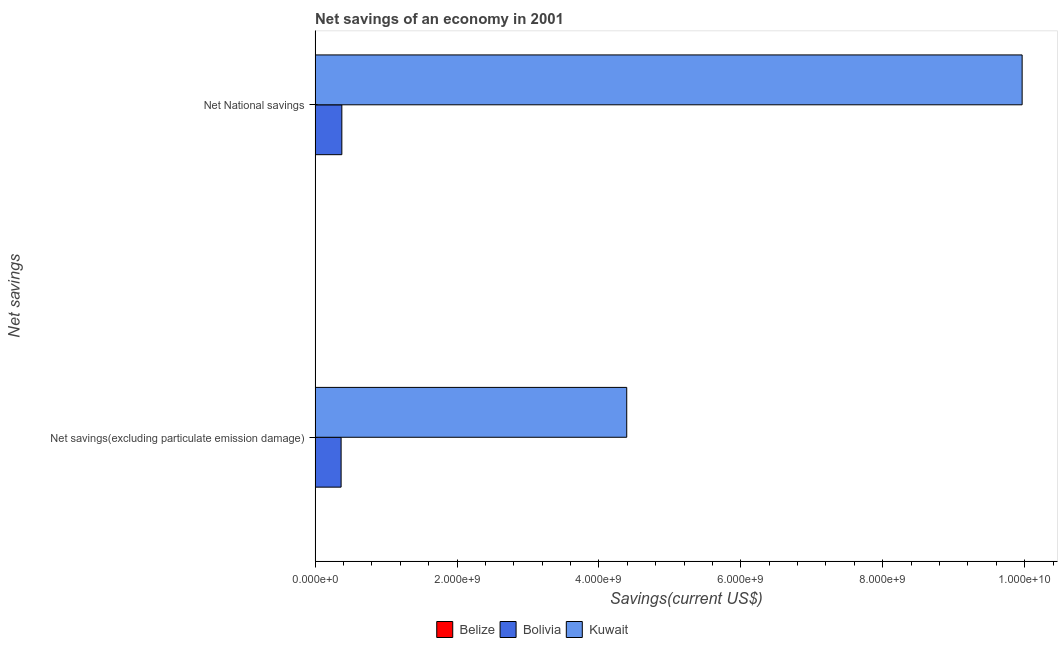How many different coloured bars are there?
Your answer should be very brief. 2. How many groups of bars are there?
Offer a terse response. 2. Are the number of bars per tick equal to the number of legend labels?
Your answer should be compact. No. Are the number of bars on each tick of the Y-axis equal?
Your response must be concise. Yes. What is the label of the 1st group of bars from the top?
Your response must be concise. Net National savings. What is the net national savings in Kuwait?
Offer a very short reply. 9.97e+09. Across all countries, what is the maximum net savings(excluding particulate emission damage)?
Your answer should be very brief. 4.39e+09. In which country was the net national savings maximum?
Provide a short and direct response. Kuwait. What is the total net savings(excluding particulate emission damage) in the graph?
Your response must be concise. 4.76e+09. What is the difference between the net savings(excluding particulate emission damage) in Bolivia and that in Kuwait?
Offer a very short reply. -4.03e+09. What is the difference between the net savings(excluding particulate emission damage) in Belize and the net national savings in Bolivia?
Make the answer very short. -3.77e+08. What is the average net savings(excluding particulate emission damage) per country?
Keep it short and to the point. 1.59e+09. What is the difference between the net savings(excluding particulate emission damage) and net national savings in Kuwait?
Give a very brief answer. -5.57e+09. What is the ratio of the net savings(excluding particulate emission damage) in Kuwait to that in Bolivia?
Your response must be concise. 11.99. In how many countries, is the net national savings greater than the average net national savings taken over all countries?
Offer a very short reply. 1. Are all the bars in the graph horizontal?
Keep it short and to the point. Yes. What is the difference between two consecutive major ticks on the X-axis?
Ensure brevity in your answer.  2.00e+09. Does the graph contain grids?
Provide a short and direct response. No. Where does the legend appear in the graph?
Provide a succinct answer. Bottom center. How many legend labels are there?
Give a very brief answer. 3. How are the legend labels stacked?
Your response must be concise. Horizontal. What is the title of the graph?
Your answer should be very brief. Net savings of an economy in 2001. What is the label or title of the X-axis?
Your answer should be compact. Savings(current US$). What is the label or title of the Y-axis?
Ensure brevity in your answer.  Net savings. What is the Savings(current US$) in Bolivia in Net savings(excluding particulate emission damage)?
Your answer should be compact. 3.66e+08. What is the Savings(current US$) in Kuwait in Net savings(excluding particulate emission damage)?
Ensure brevity in your answer.  4.39e+09. What is the Savings(current US$) in Belize in Net National savings?
Your answer should be very brief. 0. What is the Savings(current US$) of Bolivia in Net National savings?
Provide a short and direct response. 3.77e+08. What is the Savings(current US$) in Kuwait in Net National savings?
Give a very brief answer. 9.97e+09. Across all Net savings, what is the maximum Savings(current US$) of Bolivia?
Give a very brief answer. 3.77e+08. Across all Net savings, what is the maximum Savings(current US$) in Kuwait?
Provide a succinct answer. 9.97e+09. Across all Net savings, what is the minimum Savings(current US$) in Bolivia?
Provide a short and direct response. 3.66e+08. Across all Net savings, what is the minimum Savings(current US$) of Kuwait?
Keep it short and to the point. 4.39e+09. What is the total Savings(current US$) of Belize in the graph?
Provide a short and direct response. 0. What is the total Savings(current US$) in Bolivia in the graph?
Your answer should be very brief. 7.43e+08. What is the total Savings(current US$) of Kuwait in the graph?
Keep it short and to the point. 1.44e+1. What is the difference between the Savings(current US$) of Bolivia in Net savings(excluding particulate emission damage) and that in Net National savings?
Your response must be concise. -1.05e+07. What is the difference between the Savings(current US$) in Kuwait in Net savings(excluding particulate emission damage) and that in Net National savings?
Offer a very short reply. -5.57e+09. What is the difference between the Savings(current US$) in Bolivia in Net savings(excluding particulate emission damage) and the Savings(current US$) in Kuwait in Net National savings?
Your answer should be very brief. -9.60e+09. What is the average Savings(current US$) of Bolivia per Net savings?
Keep it short and to the point. 3.72e+08. What is the average Savings(current US$) of Kuwait per Net savings?
Offer a terse response. 7.18e+09. What is the difference between the Savings(current US$) in Bolivia and Savings(current US$) in Kuwait in Net savings(excluding particulate emission damage)?
Offer a terse response. -4.03e+09. What is the difference between the Savings(current US$) in Bolivia and Savings(current US$) in Kuwait in Net National savings?
Ensure brevity in your answer.  -9.59e+09. What is the ratio of the Savings(current US$) of Bolivia in Net savings(excluding particulate emission damage) to that in Net National savings?
Offer a very short reply. 0.97. What is the ratio of the Savings(current US$) in Kuwait in Net savings(excluding particulate emission damage) to that in Net National savings?
Your response must be concise. 0.44. What is the difference between the highest and the second highest Savings(current US$) of Bolivia?
Provide a succinct answer. 1.05e+07. What is the difference between the highest and the second highest Savings(current US$) of Kuwait?
Ensure brevity in your answer.  5.57e+09. What is the difference between the highest and the lowest Savings(current US$) of Bolivia?
Your answer should be compact. 1.05e+07. What is the difference between the highest and the lowest Savings(current US$) of Kuwait?
Provide a short and direct response. 5.57e+09. 